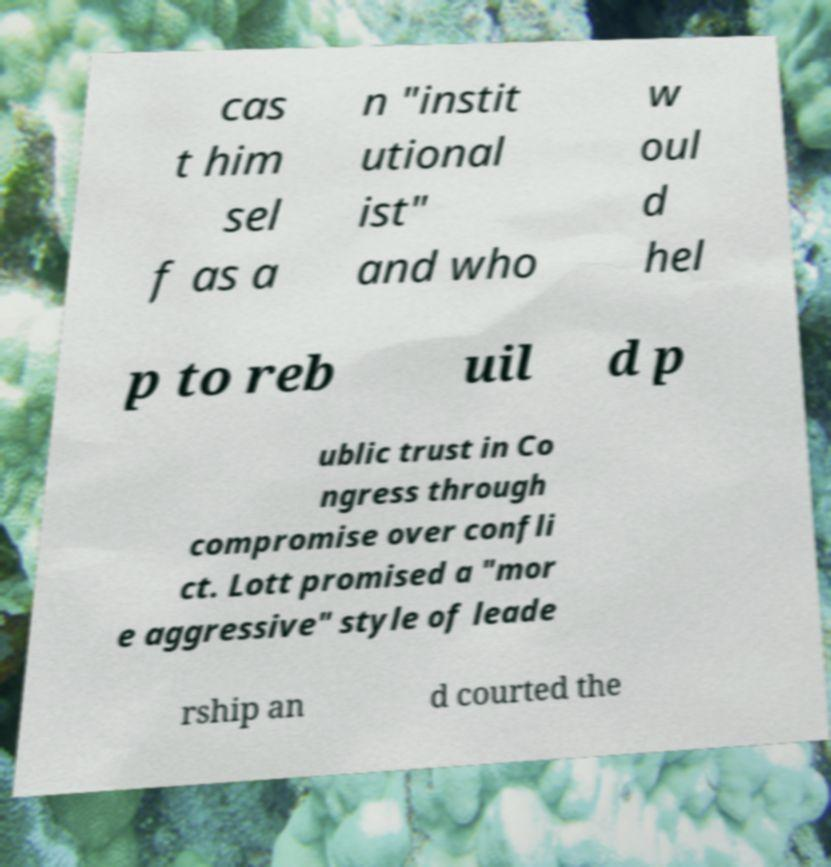For documentation purposes, I need the text within this image transcribed. Could you provide that? cas t him sel f as a n "instit utional ist" and who w oul d hel p to reb uil d p ublic trust in Co ngress through compromise over confli ct. Lott promised a "mor e aggressive" style of leade rship an d courted the 